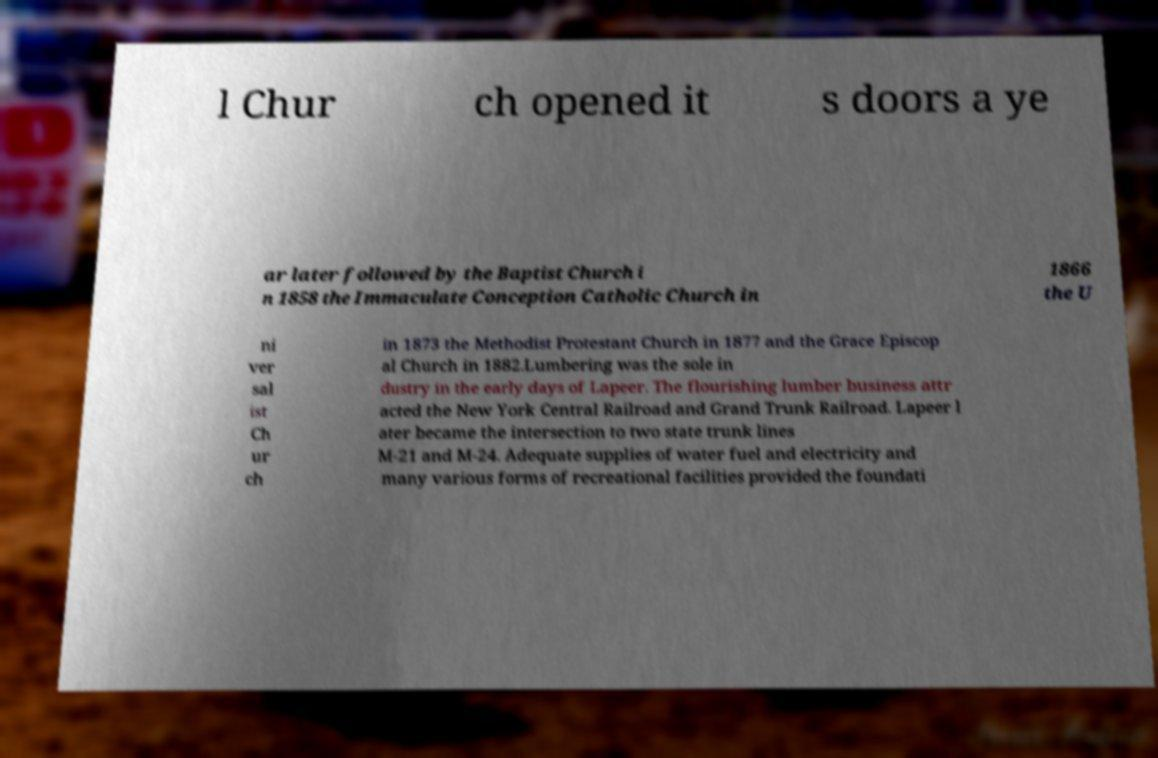Could you assist in decoding the text presented in this image and type it out clearly? l Chur ch opened it s doors a ye ar later followed by the Baptist Church i n 1858 the Immaculate Conception Catholic Church in 1866 the U ni ver sal ist Ch ur ch in 1873 the Methodist Protestant Church in 1877 and the Grace Episcop al Church in 1882.Lumbering was the sole in dustry in the early days of Lapeer. The flourishing lumber business attr acted the New York Central Railroad and Grand Trunk Railroad. Lapeer l ater became the intersection to two state trunk lines M-21 and M-24. Adequate supplies of water fuel and electricity and many various forms of recreational facilities provided the foundati 